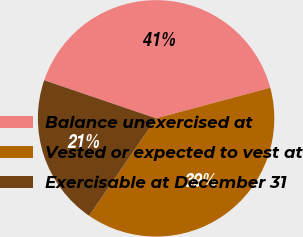Convert chart. <chart><loc_0><loc_0><loc_500><loc_500><pie_chart><fcel>Balance unexercised at<fcel>Vested or expected to vest at<fcel>Exercisable at December 31<nl><fcel>40.61%<fcel>38.76%<fcel>20.63%<nl></chart> 